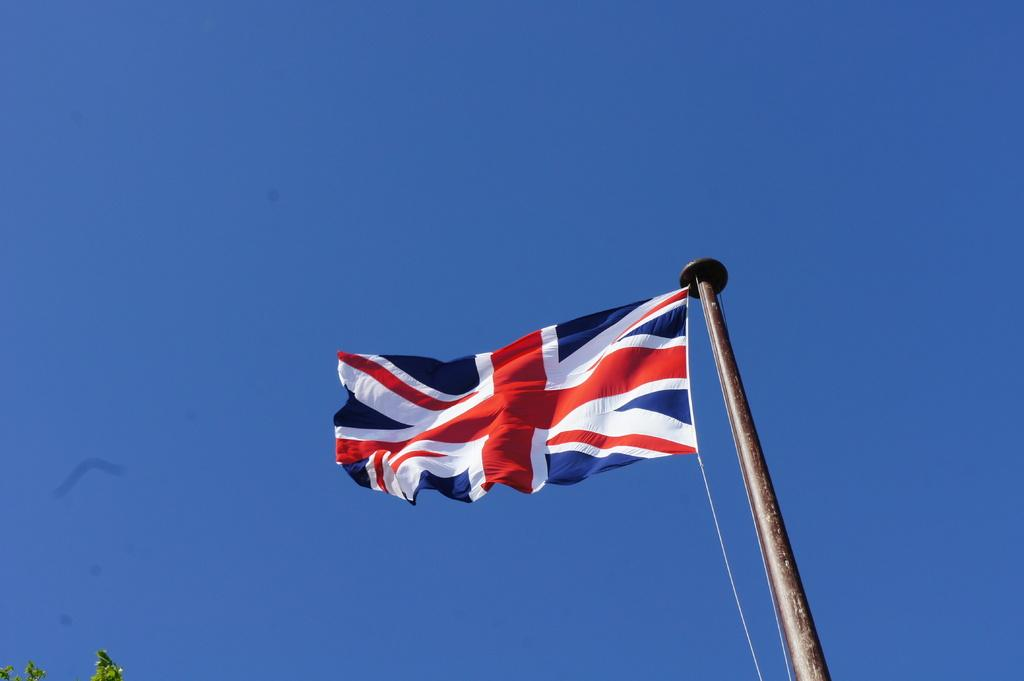What is the main subject in the center of the image? There is a flag in the center of the image. What can be seen in the background of the image? The background of the image includes the sky. What type of vegetation is visible at the bottom of the image? There are leaves visible at the bottom of the image. What type of drug is being used in the garden depicted in the image? There is no garden or drug present in the image; it features a flag and leaves in the foreground. 